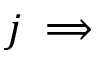<formula> <loc_0><loc_0><loc_500><loc_500>j \implies</formula> 